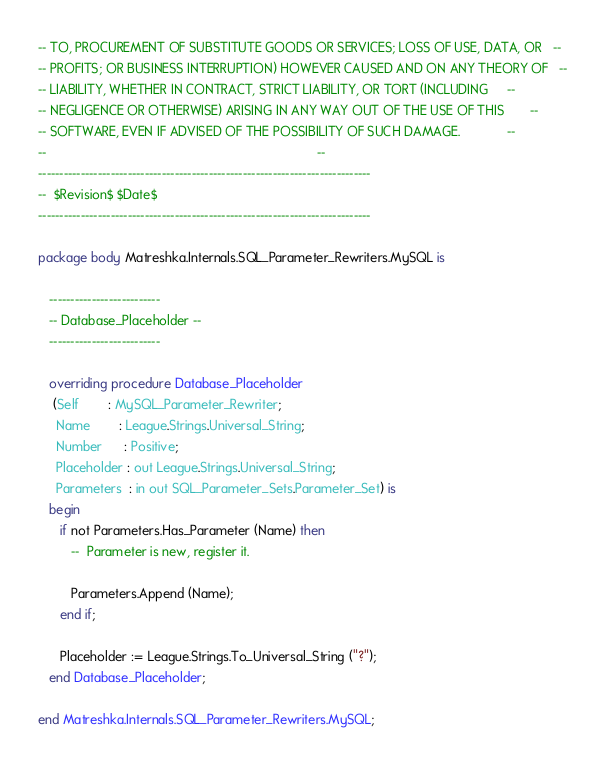Convert code to text. <code><loc_0><loc_0><loc_500><loc_500><_Ada_>-- TO, PROCUREMENT OF SUBSTITUTE GOODS OR SERVICES; LOSS OF USE, DATA, OR   --
-- PROFITS; OR BUSINESS INTERRUPTION) HOWEVER CAUSED AND ON ANY THEORY OF   --
-- LIABILITY, WHETHER IN CONTRACT, STRICT LIABILITY, OR TORT (INCLUDING     --
-- NEGLIGENCE OR OTHERWISE) ARISING IN ANY WAY OUT OF THE USE OF THIS       --
-- SOFTWARE, EVEN IF ADVISED OF THE POSSIBILITY OF SUCH DAMAGE.             --
--                                                                          --
------------------------------------------------------------------------------
--  $Revision$ $Date$
------------------------------------------------------------------------------

package body Matreshka.Internals.SQL_Parameter_Rewriters.MySQL is

   --------------------------
   -- Database_Placeholder --
   --------------------------

   overriding procedure Database_Placeholder
    (Self        : MySQL_Parameter_Rewriter;
     Name        : League.Strings.Universal_String;
     Number      : Positive;
     Placeholder : out League.Strings.Universal_String;
     Parameters  : in out SQL_Parameter_Sets.Parameter_Set) is
   begin
      if not Parameters.Has_Parameter (Name) then
         --  Parameter is new, register it.

         Parameters.Append (Name);
      end if;

      Placeholder := League.Strings.To_Universal_String ("?");
   end Database_Placeholder;

end Matreshka.Internals.SQL_Parameter_Rewriters.MySQL;
</code> 